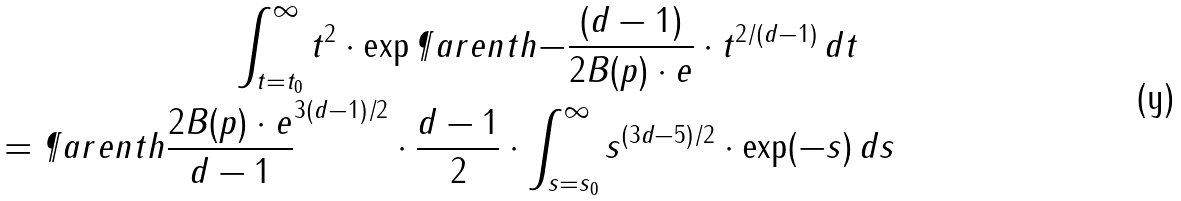Convert formula to latex. <formula><loc_0><loc_0><loc_500><loc_500>\int _ { t = t _ { 0 } } ^ { \infty } t ^ { 2 } \cdot \exp \P a r e n t h { - \frac { ( d - 1 ) } { 2 B ( p ) \cdot e } \cdot t ^ { 2 / ( d - 1 ) } } \, d t \quad \\ = \P a r e n t h { \frac { 2 B ( p ) \cdot e } { d - 1 } } ^ { 3 ( d - 1 ) / 2 } \cdot \frac { d - 1 } 2 \cdot \int _ { s = s _ { 0 } } ^ { \infty } s ^ { ( 3 d - 5 ) / 2 } \cdot \exp ( - s ) \, d s</formula> 